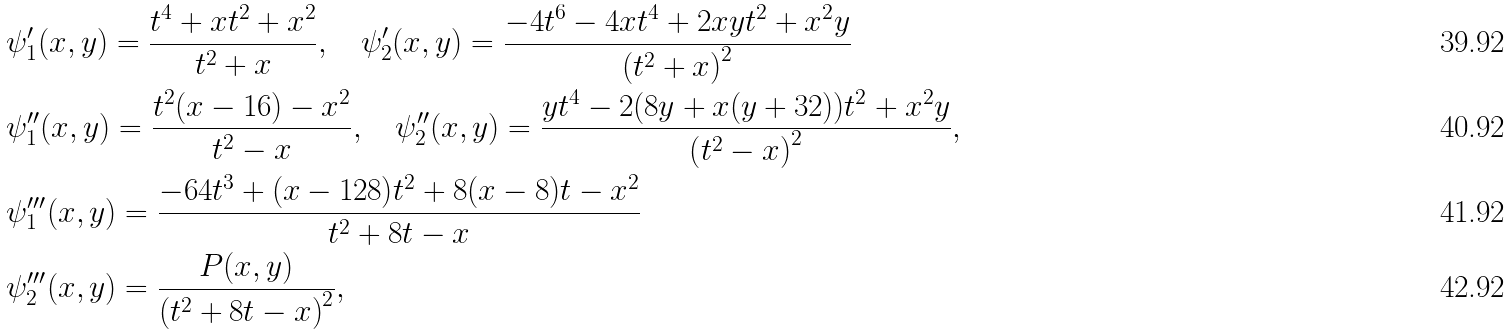<formula> <loc_0><loc_0><loc_500><loc_500>& \psi ^ { \prime } _ { 1 } ( x , y ) = \frac { t ^ { 4 } + x t ^ { 2 } + x ^ { 2 } } { t ^ { 2 } + x } , \quad \psi ^ { \prime } _ { 2 } ( x , y ) = \frac { - 4 t ^ { 6 } - 4 x t ^ { 4 } + 2 x y t ^ { 2 } + x ^ { 2 } y } { \left ( t ^ { 2 } + x \right ) ^ { 2 } } \\ & \psi ^ { \prime \prime } _ { 1 } ( x , y ) = \frac { t ^ { 2 } ( x - 1 6 ) - x ^ { 2 } } { t ^ { 2 } - x } , \quad \psi ^ { \prime \prime } _ { 2 } ( x , y ) = \frac { y t ^ { 4 } - 2 ( 8 y + x ( y + 3 2 ) ) t ^ { 2 } + x ^ { 2 } y } { \left ( t ^ { 2 } - x \right ) ^ { 2 } } , & \\ & \psi ^ { \prime \prime \prime } _ { 1 } ( x , y ) = \frac { - 6 4 t ^ { 3 } + ( x - 1 2 8 ) t ^ { 2 } + 8 ( x - 8 ) t - x ^ { 2 } } { t ^ { 2 } + 8 t - x } \\ & \psi ^ { \prime \prime \prime } _ { 2 } ( x , y ) = \frac { P ( x , y ) } { \left ( t ^ { 2 } + 8 t - x \right ) ^ { 2 } } ,</formula> 